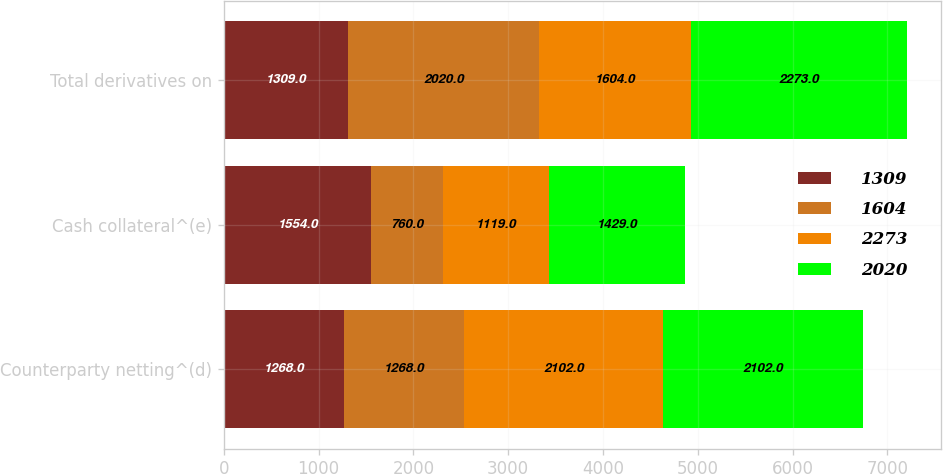Convert chart to OTSL. <chart><loc_0><loc_0><loc_500><loc_500><stacked_bar_chart><ecel><fcel>Counterparty netting^(d)<fcel>Cash collateral^(e)<fcel>Total derivatives on<nl><fcel>1309<fcel>1268<fcel>1554<fcel>1309<nl><fcel>1604<fcel>1268<fcel>760<fcel>2020<nl><fcel>2273<fcel>2102<fcel>1119<fcel>1604<nl><fcel>2020<fcel>2102<fcel>1429<fcel>2273<nl></chart> 